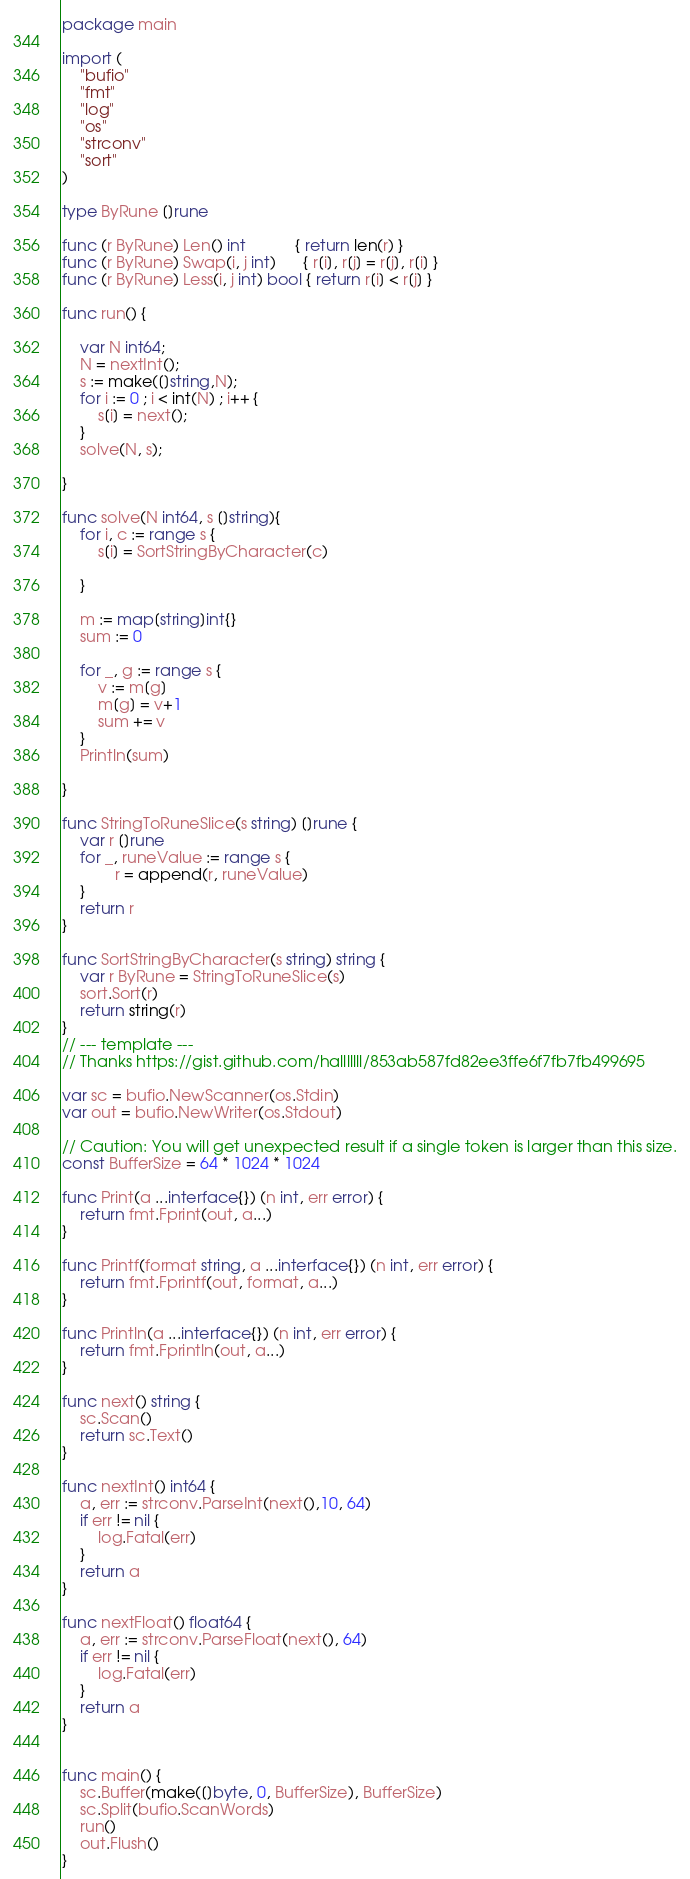Convert code to text. <code><loc_0><loc_0><loc_500><loc_500><_Go_>package main
 
import (
	"bufio"
	"fmt"
	"log"
	"os"
	"strconv"
	"sort"
)
 
type ByRune []rune

func (r ByRune) Len() int           { return len(r) }
func (r ByRune) Swap(i, j int)      { r[i], r[j] = r[j], r[i] }
func (r ByRune) Less(i, j int) bool { return r[i] < r[j] }

func run() {

	var N int64;
    N = nextInt();
    s := make([]string,N);
    for i := 0 ; i < int(N) ; i++ {
        s[i] = next();
    }
	solve(N, s);

}

func solve(N int64, s []string){	  
	for i, c := range s {
		s[i] = SortStringByCharacter(c)

	}
	
	m := map[string]int{}
	sum := 0

	for _, g := range s {
		v := m[g]
		m[g] = v+1
		sum += v
	}
	Println(sum)
	
}

func StringToRuneSlice(s string) []rune {
	var r []rune
	for _, runeValue := range s {
			r = append(r, runeValue)
	}
	return r
}

func SortStringByCharacter(s string) string {
	var r ByRune = StringToRuneSlice(s)
	sort.Sort(r)
	return string(r)
}
// --- template ---
// Thanks https://gist.github.com/halllllll/853ab587fd82ee3ffe6f7fb7fb499695
 
var sc = bufio.NewScanner(os.Stdin)
var out = bufio.NewWriter(os.Stdout)
 
// Caution: You will get unexpected result if a single token is larger than this size.
const BufferSize = 64 * 1024 * 1024
 
func Print(a ...interface{}) (n int, err error) {
	return fmt.Fprint(out, a...)
}
 
func Printf(format string, a ...interface{}) (n int, err error) {
	return fmt.Fprintf(out, format, a...)
}
 
func Println(a ...interface{}) (n int, err error) {
	return fmt.Fprintln(out, a...)
}
 
func next() string {
	sc.Scan()
	return sc.Text()
}
 
func nextInt() int64 {
	a, err := strconv.ParseInt(next(),10, 64)
	if err != nil {
		log.Fatal(err)
	}
	return a
}

func nextFloat() float64 {
	a, err := strconv.ParseFloat(next(), 64)
	if err != nil {
		log.Fatal(err)
	}
	return a
}

 
func main() {
	sc.Buffer(make([]byte, 0, BufferSize), BufferSize)
	sc.Split(bufio.ScanWords)
	run()
	out.Flush()
}
</code> 